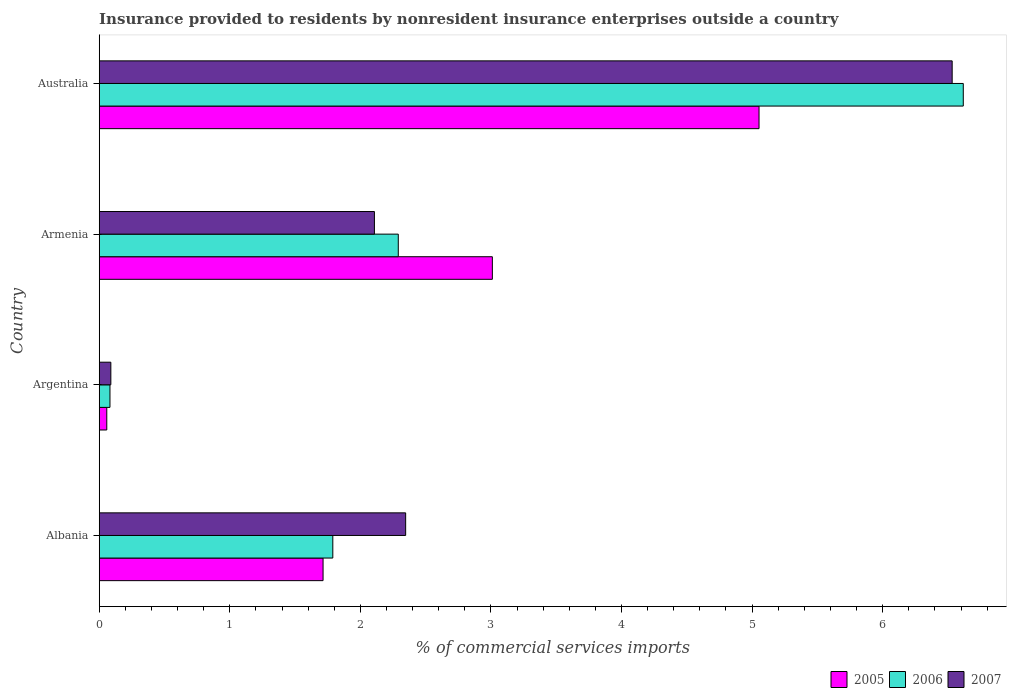How many different coloured bars are there?
Give a very brief answer. 3. Are the number of bars per tick equal to the number of legend labels?
Provide a short and direct response. Yes. Are the number of bars on each tick of the Y-axis equal?
Offer a very short reply. Yes. What is the label of the 3rd group of bars from the top?
Your answer should be very brief. Argentina. In how many cases, is the number of bars for a given country not equal to the number of legend labels?
Your response must be concise. 0. What is the Insurance provided to residents in 2005 in Albania?
Provide a short and direct response. 1.71. Across all countries, what is the maximum Insurance provided to residents in 2006?
Your answer should be compact. 6.62. Across all countries, what is the minimum Insurance provided to residents in 2007?
Offer a very short reply. 0.09. In which country was the Insurance provided to residents in 2006 maximum?
Provide a short and direct response. Australia. What is the total Insurance provided to residents in 2005 in the graph?
Provide a short and direct response. 9.84. What is the difference between the Insurance provided to residents in 2006 in Argentina and that in Australia?
Ensure brevity in your answer.  -6.54. What is the difference between the Insurance provided to residents in 2006 in Armenia and the Insurance provided to residents in 2005 in Australia?
Ensure brevity in your answer.  -2.76. What is the average Insurance provided to residents in 2005 per country?
Offer a very short reply. 2.46. What is the difference between the Insurance provided to residents in 2005 and Insurance provided to residents in 2006 in Australia?
Your answer should be compact. -1.56. In how many countries, is the Insurance provided to residents in 2007 greater than 3.6 %?
Your response must be concise. 1. What is the ratio of the Insurance provided to residents in 2006 in Argentina to that in Australia?
Provide a short and direct response. 0.01. Is the difference between the Insurance provided to residents in 2005 in Armenia and Australia greater than the difference between the Insurance provided to residents in 2006 in Armenia and Australia?
Your answer should be compact. Yes. What is the difference between the highest and the second highest Insurance provided to residents in 2007?
Provide a succinct answer. 4.19. What is the difference between the highest and the lowest Insurance provided to residents in 2007?
Offer a very short reply. 6.44. In how many countries, is the Insurance provided to residents in 2005 greater than the average Insurance provided to residents in 2005 taken over all countries?
Provide a succinct answer. 2. Is the sum of the Insurance provided to residents in 2006 in Albania and Argentina greater than the maximum Insurance provided to residents in 2007 across all countries?
Your response must be concise. No. What does the 2nd bar from the top in Australia represents?
Keep it short and to the point. 2006. How many bars are there?
Your answer should be very brief. 12. Does the graph contain any zero values?
Make the answer very short. No. How many legend labels are there?
Your answer should be very brief. 3. How are the legend labels stacked?
Give a very brief answer. Horizontal. What is the title of the graph?
Offer a terse response. Insurance provided to residents by nonresident insurance enterprises outside a country. What is the label or title of the X-axis?
Ensure brevity in your answer.  % of commercial services imports. What is the % of commercial services imports of 2005 in Albania?
Give a very brief answer. 1.71. What is the % of commercial services imports in 2006 in Albania?
Provide a succinct answer. 1.79. What is the % of commercial services imports in 2007 in Albania?
Make the answer very short. 2.35. What is the % of commercial services imports in 2005 in Argentina?
Provide a succinct answer. 0.06. What is the % of commercial services imports in 2006 in Argentina?
Ensure brevity in your answer.  0.08. What is the % of commercial services imports in 2007 in Argentina?
Make the answer very short. 0.09. What is the % of commercial services imports in 2005 in Armenia?
Offer a very short reply. 3.01. What is the % of commercial services imports of 2006 in Armenia?
Offer a very short reply. 2.29. What is the % of commercial services imports in 2007 in Armenia?
Ensure brevity in your answer.  2.11. What is the % of commercial services imports in 2005 in Australia?
Give a very brief answer. 5.05. What is the % of commercial services imports of 2006 in Australia?
Make the answer very short. 6.62. What is the % of commercial services imports in 2007 in Australia?
Provide a succinct answer. 6.53. Across all countries, what is the maximum % of commercial services imports of 2005?
Your answer should be very brief. 5.05. Across all countries, what is the maximum % of commercial services imports in 2006?
Offer a terse response. 6.62. Across all countries, what is the maximum % of commercial services imports in 2007?
Provide a succinct answer. 6.53. Across all countries, what is the minimum % of commercial services imports in 2005?
Your answer should be compact. 0.06. Across all countries, what is the minimum % of commercial services imports in 2006?
Offer a terse response. 0.08. Across all countries, what is the minimum % of commercial services imports in 2007?
Give a very brief answer. 0.09. What is the total % of commercial services imports in 2005 in the graph?
Provide a succinct answer. 9.84. What is the total % of commercial services imports in 2006 in the graph?
Make the answer very short. 10.78. What is the total % of commercial services imports of 2007 in the graph?
Make the answer very short. 11.08. What is the difference between the % of commercial services imports of 2005 in Albania and that in Argentina?
Your answer should be compact. 1.66. What is the difference between the % of commercial services imports of 2006 in Albania and that in Argentina?
Make the answer very short. 1.71. What is the difference between the % of commercial services imports in 2007 in Albania and that in Argentina?
Keep it short and to the point. 2.26. What is the difference between the % of commercial services imports of 2005 in Albania and that in Armenia?
Your response must be concise. -1.3. What is the difference between the % of commercial services imports of 2006 in Albania and that in Armenia?
Your answer should be very brief. -0.5. What is the difference between the % of commercial services imports of 2007 in Albania and that in Armenia?
Offer a terse response. 0.24. What is the difference between the % of commercial services imports in 2005 in Albania and that in Australia?
Offer a terse response. -3.34. What is the difference between the % of commercial services imports in 2006 in Albania and that in Australia?
Offer a very short reply. -4.83. What is the difference between the % of commercial services imports in 2007 in Albania and that in Australia?
Keep it short and to the point. -4.19. What is the difference between the % of commercial services imports of 2005 in Argentina and that in Armenia?
Your response must be concise. -2.95. What is the difference between the % of commercial services imports of 2006 in Argentina and that in Armenia?
Your response must be concise. -2.21. What is the difference between the % of commercial services imports in 2007 in Argentina and that in Armenia?
Your response must be concise. -2.02. What is the difference between the % of commercial services imports in 2005 in Argentina and that in Australia?
Keep it short and to the point. -5. What is the difference between the % of commercial services imports in 2006 in Argentina and that in Australia?
Make the answer very short. -6.54. What is the difference between the % of commercial services imports in 2007 in Argentina and that in Australia?
Ensure brevity in your answer.  -6.44. What is the difference between the % of commercial services imports of 2005 in Armenia and that in Australia?
Your response must be concise. -2.04. What is the difference between the % of commercial services imports of 2006 in Armenia and that in Australia?
Keep it short and to the point. -4.33. What is the difference between the % of commercial services imports in 2007 in Armenia and that in Australia?
Ensure brevity in your answer.  -4.42. What is the difference between the % of commercial services imports in 2005 in Albania and the % of commercial services imports in 2006 in Argentina?
Offer a very short reply. 1.63. What is the difference between the % of commercial services imports of 2005 in Albania and the % of commercial services imports of 2007 in Argentina?
Your response must be concise. 1.63. What is the difference between the % of commercial services imports in 2006 in Albania and the % of commercial services imports in 2007 in Argentina?
Provide a short and direct response. 1.7. What is the difference between the % of commercial services imports of 2005 in Albania and the % of commercial services imports of 2006 in Armenia?
Make the answer very short. -0.58. What is the difference between the % of commercial services imports of 2005 in Albania and the % of commercial services imports of 2007 in Armenia?
Your answer should be very brief. -0.39. What is the difference between the % of commercial services imports of 2006 in Albania and the % of commercial services imports of 2007 in Armenia?
Make the answer very short. -0.32. What is the difference between the % of commercial services imports in 2005 in Albania and the % of commercial services imports in 2006 in Australia?
Offer a terse response. -4.9. What is the difference between the % of commercial services imports of 2005 in Albania and the % of commercial services imports of 2007 in Australia?
Make the answer very short. -4.82. What is the difference between the % of commercial services imports of 2006 in Albania and the % of commercial services imports of 2007 in Australia?
Your response must be concise. -4.74. What is the difference between the % of commercial services imports in 2005 in Argentina and the % of commercial services imports in 2006 in Armenia?
Provide a short and direct response. -2.23. What is the difference between the % of commercial services imports in 2005 in Argentina and the % of commercial services imports in 2007 in Armenia?
Ensure brevity in your answer.  -2.05. What is the difference between the % of commercial services imports in 2006 in Argentina and the % of commercial services imports in 2007 in Armenia?
Your answer should be compact. -2.03. What is the difference between the % of commercial services imports of 2005 in Argentina and the % of commercial services imports of 2006 in Australia?
Give a very brief answer. -6.56. What is the difference between the % of commercial services imports in 2005 in Argentina and the % of commercial services imports in 2007 in Australia?
Make the answer very short. -6.47. What is the difference between the % of commercial services imports in 2006 in Argentina and the % of commercial services imports in 2007 in Australia?
Provide a succinct answer. -6.45. What is the difference between the % of commercial services imports of 2005 in Armenia and the % of commercial services imports of 2006 in Australia?
Make the answer very short. -3.61. What is the difference between the % of commercial services imports of 2005 in Armenia and the % of commercial services imports of 2007 in Australia?
Your answer should be very brief. -3.52. What is the difference between the % of commercial services imports in 2006 in Armenia and the % of commercial services imports in 2007 in Australia?
Ensure brevity in your answer.  -4.24. What is the average % of commercial services imports of 2005 per country?
Offer a terse response. 2.46. What is the average % of commercial services imports in 2006 per country?
Offer a very short reply. 2.69. What is the average % of commercial services imports in 2007 per country?
Your answer should be very brief. 2.77. What is the difference between the % of commercial services imports in 2005 and % of commercial services imports in 2006 in Albania?
Your response must be concise. -0.07. What is the difference between the % of commercial services imports of 2005 and % of commercial services imports of 2007 in Albania?
Provide a short and direct response. -0.63. What is the difference between the % of commercial services imports of 2006 and % of commercial services imports of 2007 in Albania?
Your answer should be compact. -0.56. What is the difference between the % of commercial services imports in 2005 and % of commercial services imports in 2006 in Argentina?
Your answer should be very brief. -0.02. What is the difference between the % of commercial services imports in 2005 and % of commercial services imports in 2007 in Argentina?
Provide a short and direct response. -0.03. What is the difference between the % of commercial services imports in 2006 and % of commercial services imports in 2007 in Argentina?
Provide a succinct answer. -0.01. What is the difference between the % of commercial services imports of 2005 and % of commercial services imports of 2006 in Armenia?
Give a very brief answer. 0.72. What is the difference between the % of commercial services imports in 2005 and % of commercial services imports in 2007 in Armenia?
Your answer should be compact. 0.9. What is the difference between the % of commercial services imports of 2006 and % of commercial services imports of 2007 in Armenia?
Keep it short and to the point. 0.18. What is the difference between the % of commercial services imports of 2005 and % of commercial services imports of 2006 in Australia?
Keep it short and to the point. -1.56. What is the difference between the % of commercial services imports in 2005 and % of commercial services imports in 2007 in Australia?
Keep it short and to the point. -1.48. What is the difference between the % of commercial services imports of 2006 and % of commercial services imports of 2007 in Australia?
Provide a short and direct response. 0.09. What is the ratio of the % of commercial services imports in 2005 in Albania to that in Argentina?
Offer a terse response. 29.6. What is the ratio of the % of commercial services imports of 2006 in Albania to that in Argentina?
Your response must be concise. 21.74. What is the ratio of the % of commercial services imports in 2007 in Albania to that in Argentina?
Provide a succinct answer. 26.34. What is the ratio of the % of commercial services imports in 2005 in Albania to that in Armenia?
Offer a terse response. 0.57. What is the ratio of the % of commercial services imports in 2006 in Albania to that in Armenia?
Your answer should be very brief. 0.78. What is the ratio of the % of commercial services imports in 2007 in Albania to that in Armenia?
Offer a terse response. 1.11. What is the ratio of the % of commercial services imports in 2005 in Albania to that in Australia?
Your answer should be compact. 0.34. What is the ratio of the % of commercial services imports in 2006 in Albania to that in Australia?
Offer a very short reply. 0.27. What is the ratio of the % of commercial services imports of 2007 in Albania to that in Australia?
Keep it short and to the point. 0.36. What is the ratio of the % of commercial services imports in 2005 in Argentina to that in Armenia?
Provide a short and direct response. 0.02. What is the ratio of the % of commercial services imports of 2006 in Argentina to that in Armenia?
Give a very brief answer. 0.04. What is the ratio of the % of commercial services imports of 2007 in Argentina to that in Armenia?
Ensure brevity in your answer.  0.04. What is the ratio of the % of commercial services imports of 2005 in Argentina to that in Australia?
Your answer should be very brief. 0.01. What is the ratio of the % of commercial services imports of 2006 in Argentina to that in Australia?
Your response must be concise. 0.01. What is the ratio of the % of commercial services imports of 2007 in Argentina to that in Australia?
Ensure brevity in your answer.  0.01. What is the ratio of the % of commercial services imports of 2005 in Armenia to that in Australia?
Your answer should be compact. 0.6. What is the ratio of the % of commercial services imports of 2006 in Armenia to that in Australia?
Keep it short and to the point. 0.35. What is the ratio of the % of commercial services imports in 2007 in Armenia to that in Australia?
Your response must be concise. 0.32. What is the difference between the highest and the second highest % of commercial services imports in 2005?
Offer a very short reply. 2.04. What is the difference between the highest and the second highest % of commercial services imports in 2006?
Your answer should be very brief. 4.33. What is the difference between the highest and the second highest % of commercial services imports in 2007?
Make the answer very short. 4.19. What is the difference between the highest and the lowest % of commercial services imports in 2005?
Your answer should be very brief. 5. What is the difference between the highest and the lowest % of commercial services imports of 2006?
Offer a very short reply. 6.54. What is the difference between the highest and the lowest % of commercial services imports in 2007?
Give a very brief answer. 6.44. 